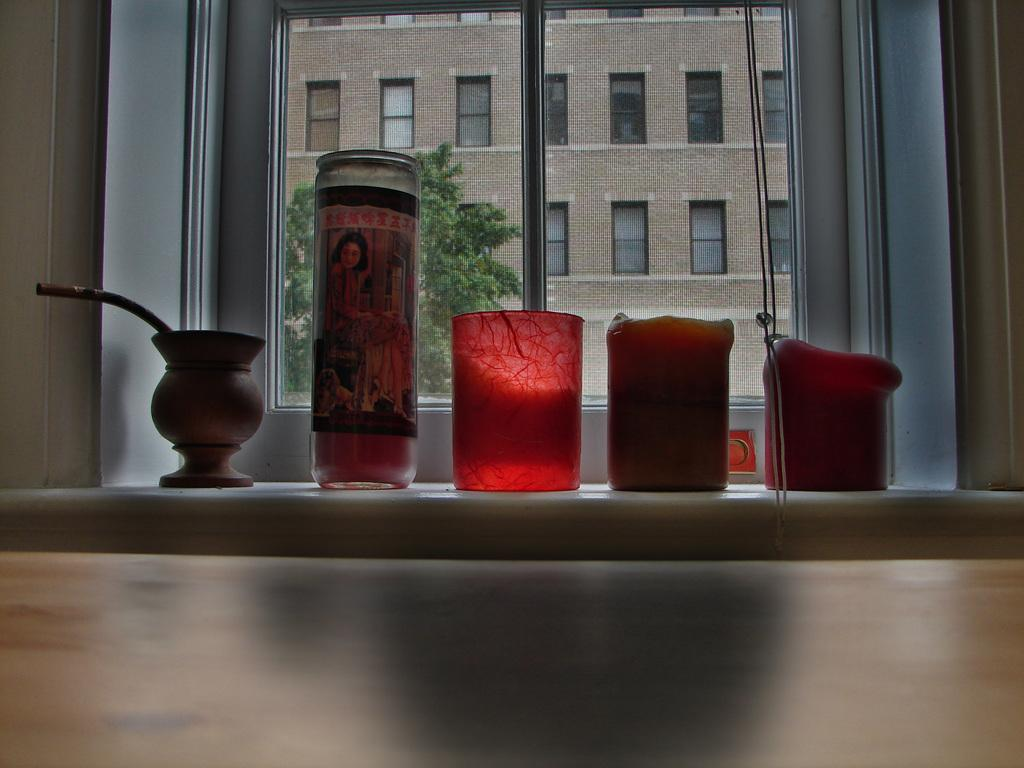What type of objects are present in the image that hold candles? There are candle glass holders in the image. What material is the holder for the candle glass holders made of? There is a wooden holder in the image. What can be seen through the glass window in the image? A tree and another building are visible through the glass window. What type of pickle is being used as a level in the image? There is no pickle present in the image, and therefore no such object is being used as a level. 